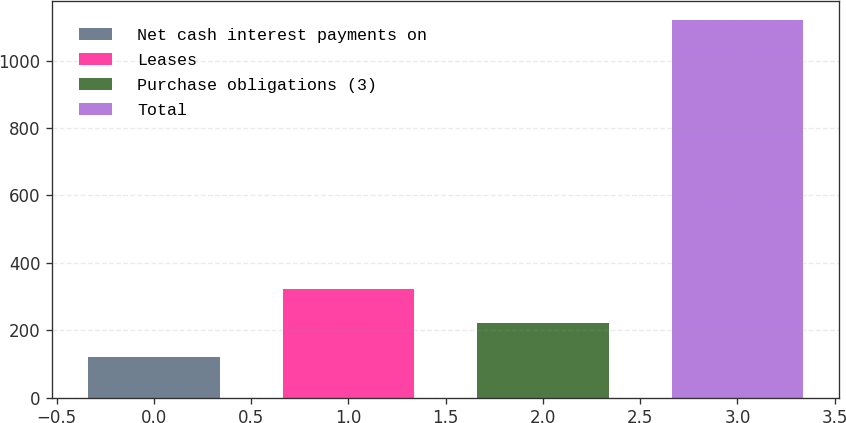Convert chart. <chart><loc_0><loc_0><loc_500><loc_500><bar_chart><fcel>Net cash interest payments on<fcel>Leases<fcel>Purchase obligations (3)<fcel>Total<nl><fcel>121<fcel>320.8<fcel>220.9<fcel>1120<nl></chart> 